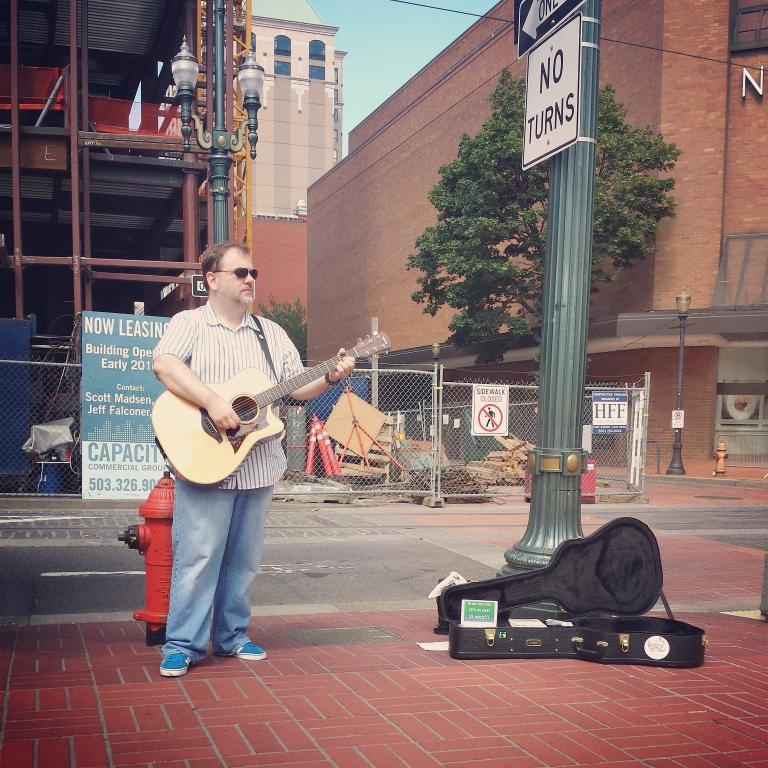What is the man in the image doing? The man is standing in the image. What is the man holding in his hand? The man is holding a guitar in his hand. What can be seen in the background of the image? There is a building and trees in the background of the image. What is written on the pole in the image? The words "No Turns" are written on a pole in the image. What color is the lead on the man's wrist in the image? There is no lead or any reference to a wrist in the image; the man is holding a guitar. 